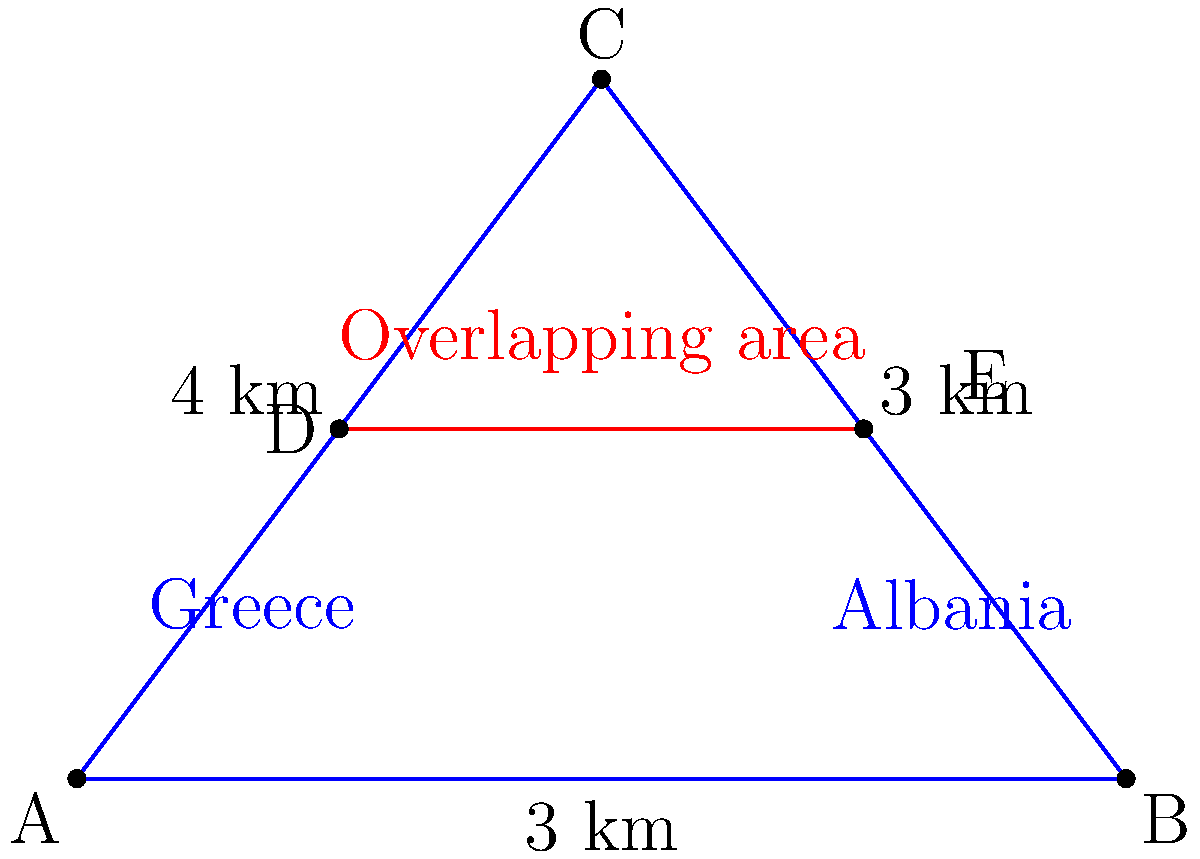Greece and Albania share a maritime border in the Ionian Sea. Their territorial waters are represented by the blue triangle ABC in the diagram. A disputed area of overlapping claims is shown by the red line DE. If the base of the triangle (AB) is 6 km and its height (from C to AB) is 4 km, what is the area of the overlapping region in square kilometers, assuming DE is parallel to AB and located halfway up the triangle's height? To solve this problem, we'll follow these steps:

1) First, calculate the area of the entire triangle ABC:
   Area of triangle = $\frac{1}{2} \times base \times height$
   $A_{ABC} = \frac{1}{2} \times 6 \times 4 = 12$ sq km

2) The overlapping region forms a trapezoid ADEB. To find its area, we need its height and the lengths of its parallel sides.

3) The height of the trapezoid is half the triangle's height:
   $h_{ADEB} = \frac{1}{2} \times 4 = 2$ km

4) To find the lengths of AD and BE, we can use the property of similar triangles:
   $\frac{AD}{AB} = \frac{DE}{AB} = \frac{1}{2}$

   So, $AD = BE = \frac{1}{2} \times 6 = 3$ km

5) Now we can calculate the area of the trapezoid:
   Area of trapezoid = $\frac{1}{2}(AD + BE) \times h_{ADEB}$
   $A_{ADEB} = \frac{1}{2}(3 + 3) \times 2 = 6$ sq km

Therefore, the area of the overlapping region is 6 square kilometers.
Answer: 6 sq km 